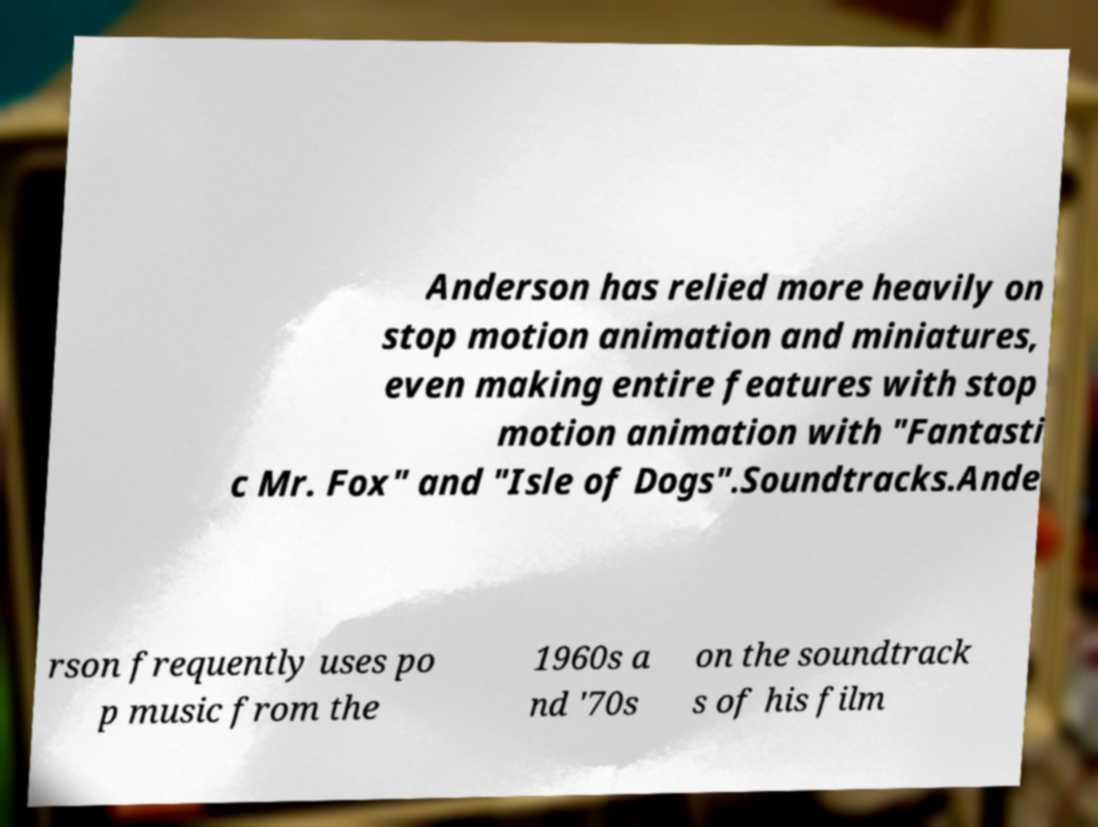I need the written content from this picture converted into text. Can you do that? Anderson has relied more heavily on stop motion animation and miniatures, even making entire features with stop motion animation with "Fantasti c Mr. Fox" and "Isle of Dogs".Soundtracks.Ande rson frequently uses po p music from the 1960s a nd '70s on the soundtrack s of his film 